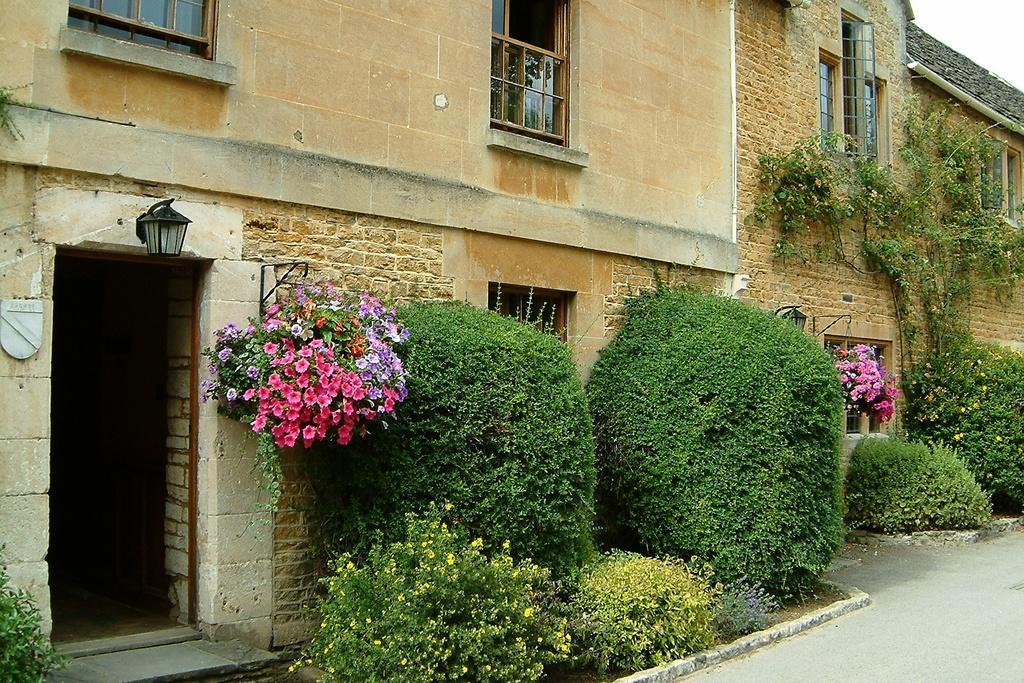Please provide a concise description of this image. In this image, there are a few people, plants and flowers. We can see the ground. We can also see some lights. 